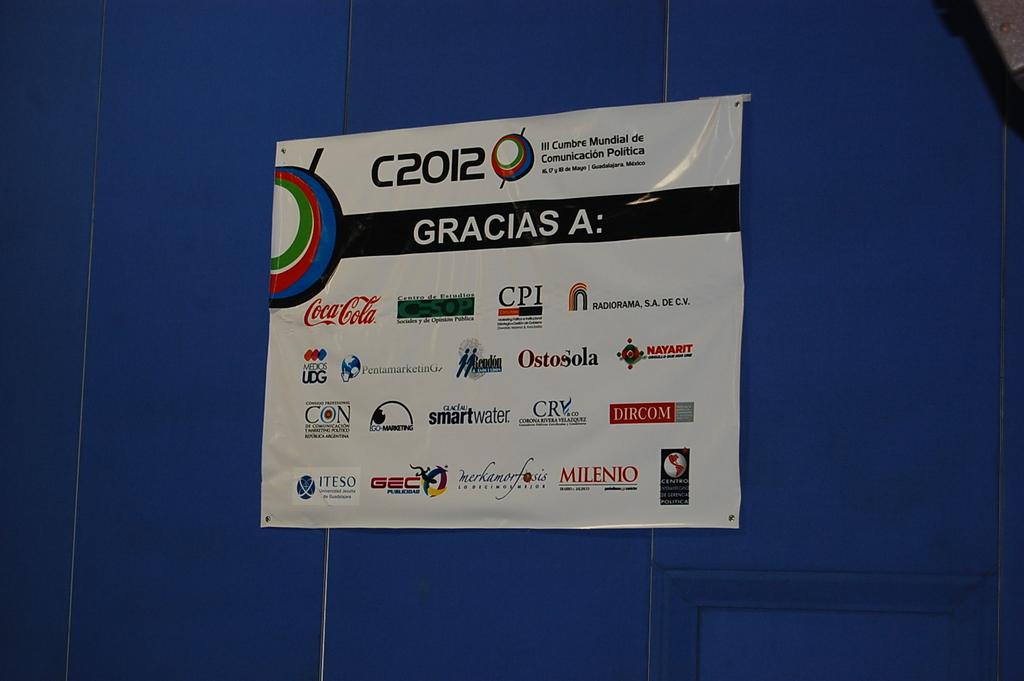Name a sponsor other than the beverage name from this display?
Keep it short and to the point. Cpi. 